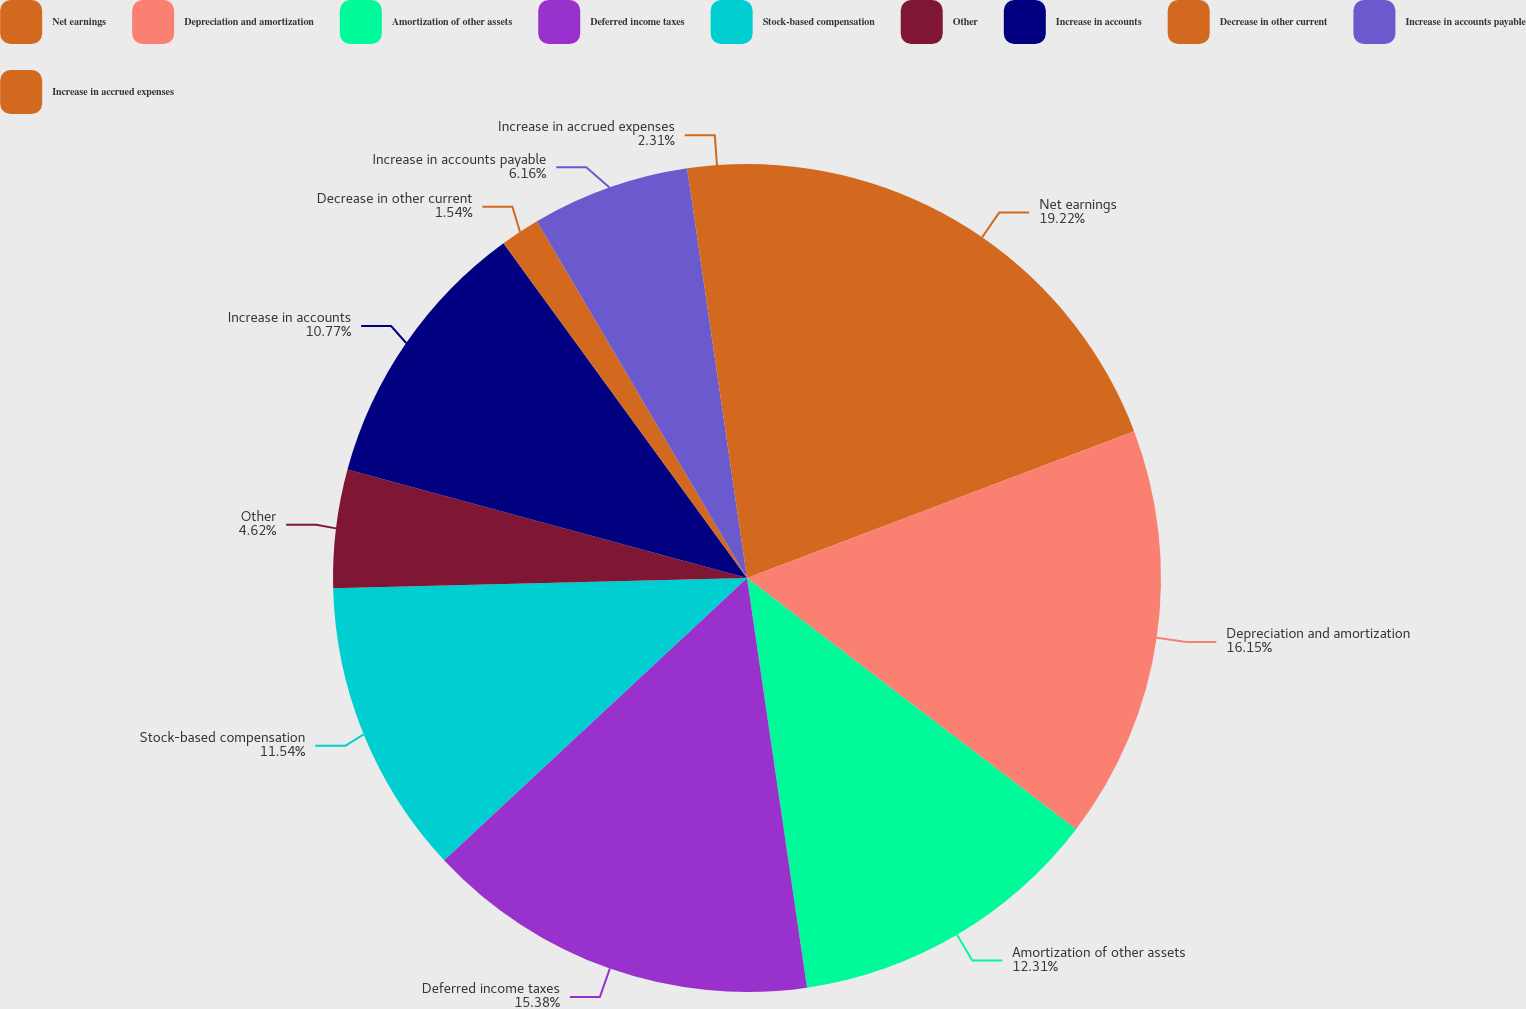Convert chart. <chart><loc_0><loc_0><loc_500><loc_500><pie_chart><fcel>Net earnings<fcel>Depreciation and amortization<fcel>Amortization of other assets<fcel>Deferred income taxes<fcel>Stock-based compensation<fcel>Other<fcel>Increase in accounts<fcel>Decrease in other current<fcel>Increase in accounts payable<fcel>Increase in accrued expenses<nl><fcel>19.23%<fcel>16.15%<fcel>12.31%<fcel>15.38%<fcel>11.54%<fcel>4.62%<fcel>10.77%<fcel>1.54%<fcel>6.16%<fcel>2.31%<nl></chart> 